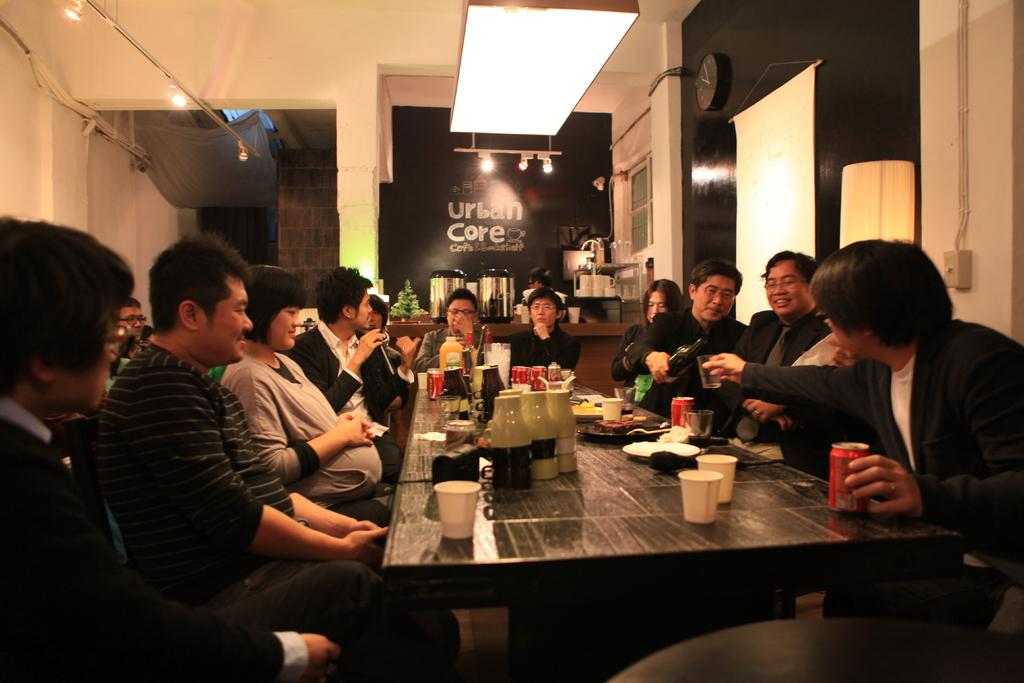What are the people in the image doing? The people in the image are sitting. What object can be seen in the image that is typically used for eating or working on a surface? There is a table in the image. What items are on the table in the image? There are glasses and a plate with a food item on the table. What type of scarecrow is standing near the people in the image? There is no scarecrow present in the image. Is there a gun visible on the table in the image? No, there is no gun visible on the table in the image. 